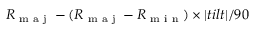<formula> <loc_0><loc_0><loc_500><loc_500>{ R \text  subscript { m a j } - { ( R \text  subscript { m a j } - R \text  subscript { \min } ) } \times | t i l t | / 9 0 }</formula> 